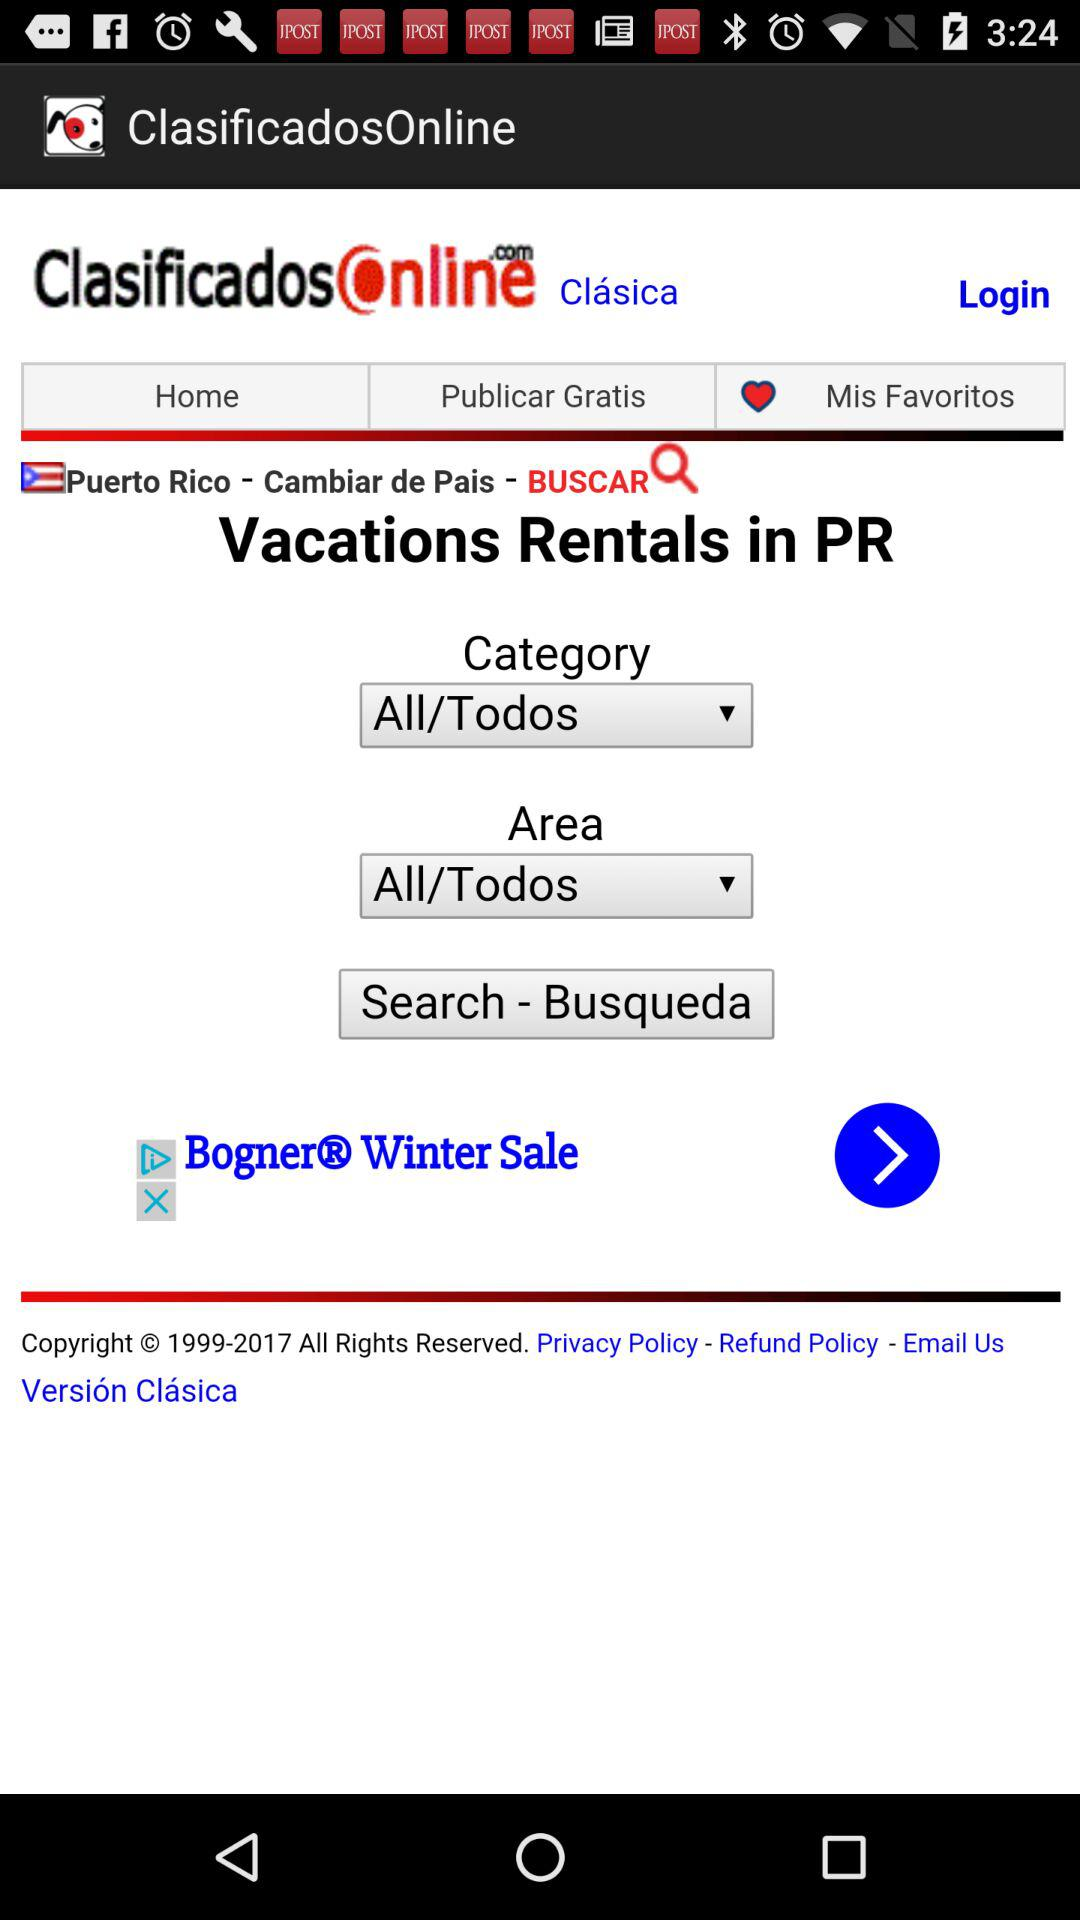What is searched?
When the provided information is insufficient, respond with <no answer>. <no answer> 